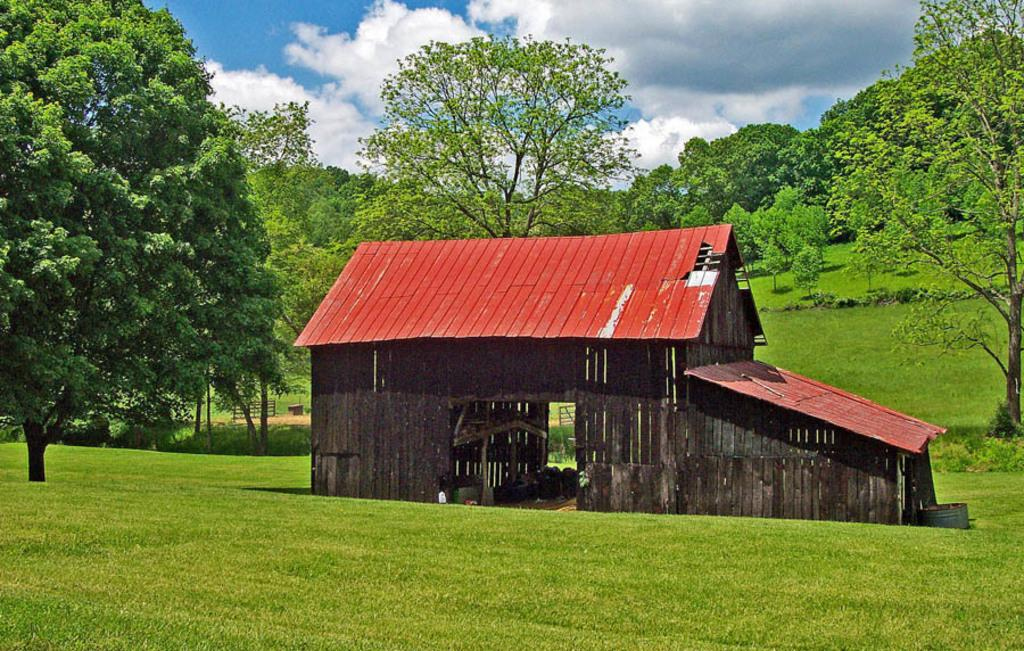What type of structure is present in the image? There is a shed in the image. What material is used for the shed's wall? The shed has a wooden wall. What is the ground surface like in the image? There is grass on the ground. What can be seen in the background? There are trees and the sky visible in the background. What is the condition of the sky in the image? The sky has clouds in it. What type of machine is being used by the angry person in the image? There is no machine or angry person present in the image. What is the mouth of the person in the image doing? There is no person present in the image, so it is not possible to determine what their mouth is doing. 